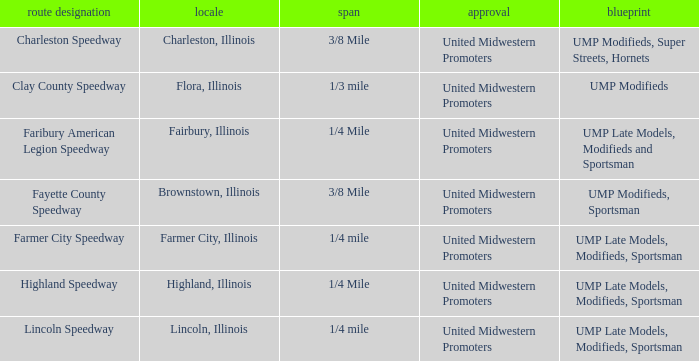Who sanctioned the event in lincoln, illinois? United Midwestern Promoters. 